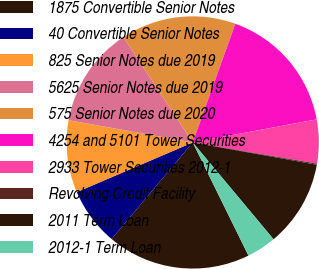<chart> <loc_0><loc_0><loc_500><loc_500><pie_chart><fcel>1875 Convertible Senior Notes<fcel>40 Convertible Senior Notes<fcel>825 Senior Notes due 2019<fcel>5625 Senior Notes due 2019<fcel>575 Senior Notes due 2020<fcel>4254 and 5101 Tower Securities<fcel>2933 Tower Securities 2012-1<fcel>Revolving Credit Facility<fcel>2011 Term Loan<fcel>2012-1 Term Loan<nl><fcel>18.4%<fcel>7.44%<fcel>9.27%<fcel>12.92%<fcel>14.75%<fcel>16.58%<fcel>5.62%<fcel>0.14%<fcel>11.1%<fcel>3.79%<nl></chart> 